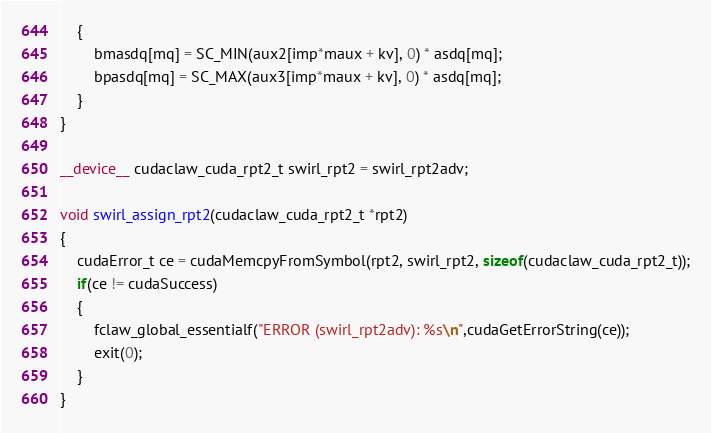Convert code to text. <code><loc_0><loc_0><loc_500><loc_500><_Cuda_>    {
        bmasdq[mq] = SC_MIN(aux2[imp*maux + kv], 0) * asdq[mq];                        
        bpasdq[mq] = SC_MAX(aux3[imp*maux + kv], 0) * asdq[mq];                                
    }
}

__device__ cudaclaw_cuda_rpt2_t swirl_rpt2 = swirl_rpt2adv;

void swirl_assign_rpt2(cudaclaw_cuda_rpt2_t *rpt2)
{
    cudaError_t ce = cudaMemcpyFromSymbol(rpt2, swirl_rpt2, sizeof(cudaclaw_cuda_rpt2_t));
    if(ce != cudaSuccess)
    {
        fclaw_global_essentialf("ERROR (swirl_rpt2adv): %s\n",cudaGetErrorString(ce));
        exit(0);
    }    
}</code> 